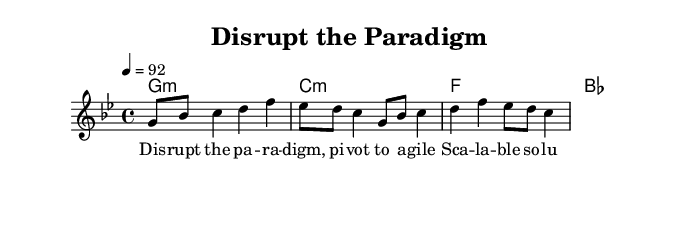What is the key signature of this music? The key signature is G minor, which is indicated by two flats (B flat and E flat). G minor is the relative minor of B flat major.
Answer: G minor What is the time signature of this music? The time signature shown at the beginning is 4/4, which indicates that there are four beats in each measure and the quarter note gets one beat.
Answer: 4/4 What is the tempo marking for this piece? The tempo marking is written as "4 = 92", indicating that there are 92 beats per minute, with each beat represented by a quarter note.
Answer: 92 How many measures are present in the melody? To determine the number of measures, we can count the distinct sets of notes separated by bar lines in the melody. Here, we find a total of 4 measures.
Answer: 4 What is the first lyric phrase in this song? The first lyric line is "Disrupt the paradigm," which is specified directly within the lyric section of the score.
Answer: Disrupt the paradigm What chord is played under the first measure? The first measure of the harmonies shows a G minor chord, which is indicated by "g1:m". This chord provides the harmonic foundation of the piece.
Answer: G minor What style of music does this piece represent? This piece is characterized by satirical hip-hop, which is indicated by the lyrics and the use of rhythmic phrasing typical in rap music.
Answer: Satirical hip-hop 